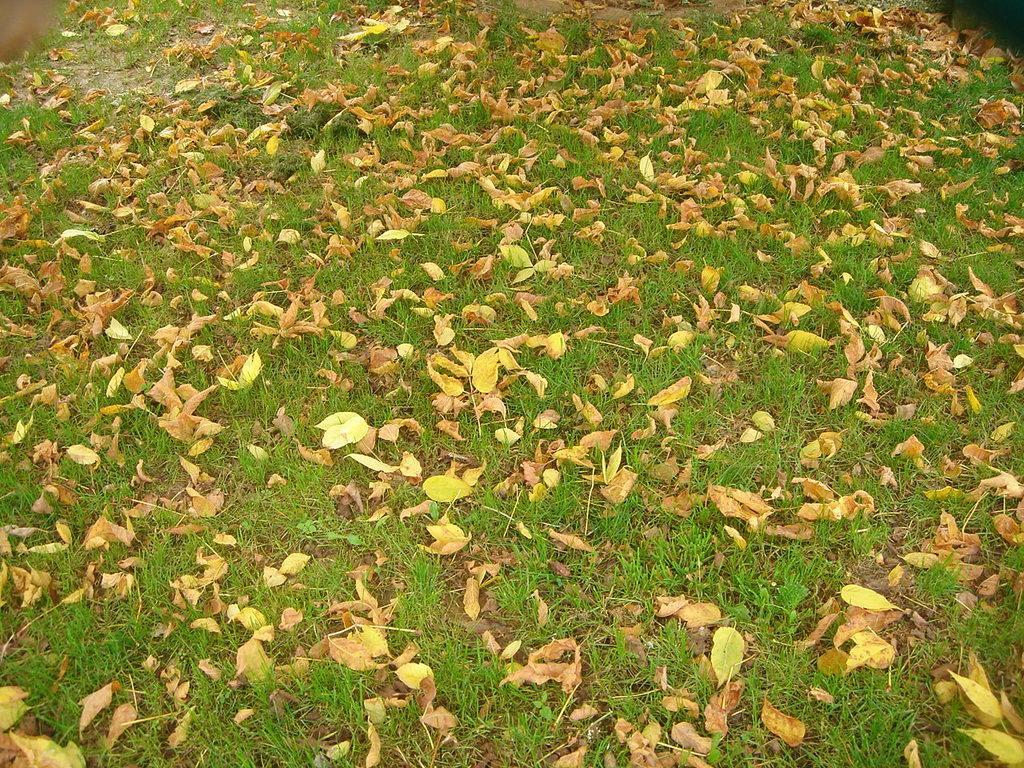Please provide a concise description of this image. In this image, we can see ground covered with leaves. 